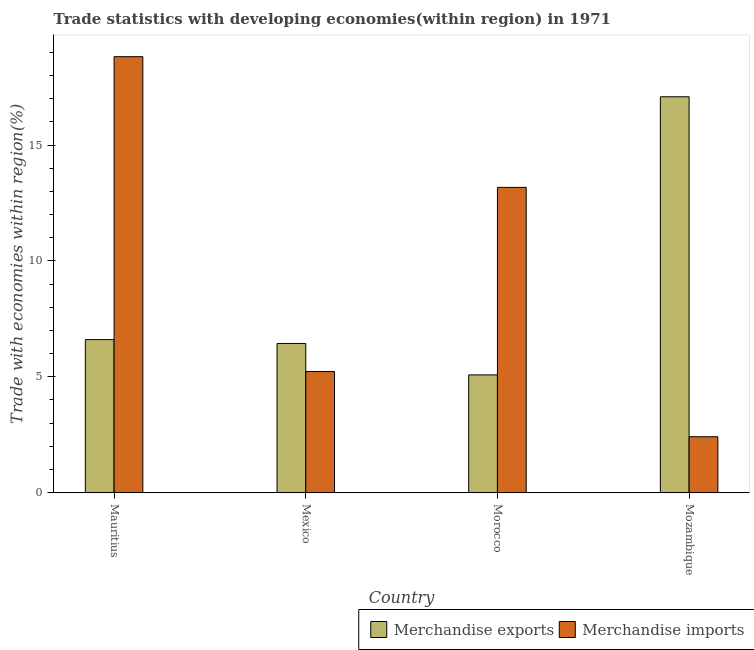How many different coloured bars are there?
Offer a very short reply. 2. How many groups of bars are there?
Give a very brief answer. 4. Are the number of bars on each tick of the X-axis equal?
Provide a short and direct response. Yes. How many bars are there on the 4th tick from the right?
Your answer should be compact. 2. What is the label of the 1st group of bars from the left?
Offer a very short reply. Mauritius. In how many cases, is the number of bars for a given country not equal to the number of legend labels?
Keep it short and to the point. 0. What is the merchandise exports in Mexico?
Ensure brevity in your answer.  6.44. Across all countries, what is the maximum merchandise exports?
Provide a short and direct response. 17.08. Across all countries, what is the minimum merchandise imports?
Give a very brief answer. 2.42. In which country was the merchandise exports maximum?
Your response must be concise. Mozambique. In which country was the merchandise imports minimum?
Give a very brief answer. Mozambique. What is the total merchandise exports in the graph?
Provide a succinct answer. 35.21. What is the difference between the merchandise imports in Mexico and that in Mozambique?
Your response must be concise. 2.81. What is the difference between the merchandise imports in Mexico and the merchandise exports in Mauritius?
Provide a short and direct response. -1.38. What is the average merchandise exports per country?
Give a very brief answer. 8.8. What is the difference between the merchandise imports and merchandise exports in Morocco?
Your answer should be compact. 8.09. In how many countries, is the merchandise imports greater than 15 %?
Make the answer very short. 1. What is the ratio of the merchandise imports in Mauritius to that in Mexico?
Provide a succinct answer. 3.6. Is the difference between the merchandise exports in Mexico and Mozambique greater than the difference between the merchandise imports in Mexico and Mozambique?
Give a very brief answer. No. What is the difference between the highest and the second highest merchandise imports?
Ensure brevity in your answer.  5.64. What is the difference between the highest and the lowest merchandise imports?
Make the answer very short. 16.39. In how many countries, is the merchandise imports greater than the average merchandise imports taken over all countries?
Your answer should be compact. 2. What does the 1st bar from the left in Mozambique represents?
Offer a very short reply. Merchandise exports. Are all the bars in the graph horizontal?
Your response must be concise. No. How many countries are there in the graph?
Offer a very short reply. 4. What is the difference between two consecutive major ticks on the Y-axis?
Provide a short and direct response. 5. Are the values on the major ticks of Y-axis written in scientific E-notation?
Offer a terse response. No. Where does the legend appear in the graph?
Keep it short and to the point. Bottom right. How many legend labels are there?
Provide a succinct answer. 2. How are the legend labels stacked?
Your response must be concise. Horizontal. What is the title of the graph?
Provide a short and direct response. Trade statistics with developing economies(within region) in 1971. What is the label or title of the X-axis?
Offer a very short reply. Country. What is the label or title of the Y-axis?
Your answer should be very brief. Trade with economies within region(%). What is the Trade with economies within region(%) of Merchandise exports in Mauritius?
Your answer should be compact. 6.6. What is the Trade with economies within region(%) in Merchandise imports in Mauritius?
Your answer should be very brief. 18.81. What is the Trade with economies within region(%) in Merchandise exports in Mexico?
Make the answer very short. 6.44. What is the Trade with economies within region(%) of Merchandise imports in Mexico?
Make the answer very short. 5.23. What is the Trade with economies within region(%) in Merchandise exports in Morocco?
Your response must be concise. 5.08. What is the Trade with economies within region(%) of Merchandise imports in Morocco?
Offer a terse response. 13.17. What is the Trade with economies within region(%) in Merchandise exports in Mozambique?
Provide a short and direct response. 17.08. What is the Trade with economies within region(%) of Merchandise imports in Mozambique?
Offer a terse response. 2.42. Across all countries, what is the maximum Trade with economies within region(%) of Merchandise exports?
Keep it short and to the point. 17.08. Across all countries, what is the maximum Trade with economies within region(%) of Merchandise imports?
Your answer should be very brief. 18.81. Across all countries, what is the minimum Trade with economies within region(%) of Merchandise exports?
Make the answer very short. 5.08. Across all countries, what is the minimum Trade with economies within region(%) in Merchandise imports?
Your answer should be very brief. 2.42. What is the total Trade with economies within region(%) in Merchandise exports in the graph?
Make the answer very short. 35.21. What is the total Trade with economies within region(%) in Merchandise imports in the graph?
Provide a succinct answer. 39.63. What is the difference between the Trade with economies within region(%) in Merchandise exports in Mauritius and that in Mexico?
Make the answer very short. 0.17. What is the difference between the Trade with economies within region(%) in Merchandise imports in Mauritius and that in Mexico?
Make the answer very short. 13.58. What is the difference between the Trade with economies within region(%) in Merchandise exports in Mauritius and that in Morocco?
Your response must be concise. 1.52. What is the difference between the Trade with economies within region(%) of Merchandise imports in Mauritius and that in Morocco?
Your response must be concise. 5.64. What is the difference between the Trade with economies within region(%) in Merchandise exports in Mauritius and that in Mozambique?
Offer a very short reply. -10.48. What is the difference between the Trade with economies within region(%) of Merchandise imports in Mauritius and that in Mozambique?
Give a very brief answer. 16.39. What is the difference between the Trade with economies within region(%) of Merchandise exports in Mexico and that in Morocco?
Ensure brevity in your answer.  1.36. What is the difference between the Trade with economies within region(%) of Merchandise imports in Mexico and that in Morocco?
Offer a very short reply. -7.94. What is the difference between the Trade with economies within region(%) of Merchandise exports in Mexico and that in Mozambique?
Make the answer very short. -10.64. What is the difference between the Trade with economies within region(%) of Merchandise imports in Mexico and that in Mozambique?
Your answer should be compact. 2.81. What is the difference between the Trade with economies within region(%) in Merchandise exports in Morocco and that in Mozambique?
Provide a short and direct response. -12. What is the difference between the Trade with economies within region(%) of Merchandise imports in Morocco and that in Mozambique?
Your response must be concise. 10.76. What is the difference between the Trade with economies within region(%) of Merchandise exports in Mauritius and the Trade with economies within region(%) of Merchandise imports in Mexico?
Offer a terse response. 1.38. What is the difference between the Trade with economies within region(%) in Merchandise exports in Mauritius and the Trade with economies within region(%) in Merchandise imports in Morocco?
Ensure brevity in your answer.  -6.57. What is the difference between the Trade with economies within region(%) in Merchandise exports in Mauritius and the Trade with economies within region(%) in Merchandise imports in Mozambique?
Your answer should be compact. 4.19. What is the difference between the Trade with economies within region(%) of Merchandise exports in Mexico and the Trade with economies within region(%) of Merchandise imports in Morocco?
Give a very brief answer. -6.73. What is the difference between the Trade with economies within region(%) in Merchandise exports in Mexico and the Trade with economies within region(%) in Merchandise imports in Mozambique?
Offer a very short reply. 4.02. What is the difference between the Trade with economies within region(%) of Merchandise exports in Morocco and the Trade with economies within region(%) of Merchandise imports in Mozambique?
Keep it short and to the point. 2.67. What is the average Trade with economies within region(%) in Merchandise exports per country?
Give a very brief answer. 8.8. What is the average Trade with economies within region(%) of Merchandise imports per country?
Your answer should be very brief. 9.91. What is the difference between the Trade with economies within region(%) of Merchandise exports and Trade with economies within region(%) of Merchandise imports in Mauritius?
Your answer should be compact. -12.21. What is the difference between the Trade with economies within region(%) in Merchandise exports and Trade with economies within region(%) in Merchandise imports in Mexico?
Offer a terse response. 1.21. What is the difference between the Trade with economies within region(%) in Merchandise exports and Trade with economies within region(%) in Merchandise imports in Morocco?
Give a very brief answer. -8.09. What is the difference between the Trade with economies within region(%) in Merchandise exports and Trade with economies within region(%) in Merchandise imports in Mozambique?
Ensure brevity in your answer.  14.67. What is the ratio of the Trade with economies within region(%) of Merchandise exports in Mauritius to that in Mexico?
Your answer should be compact. 1.03. What is the ratio of the Trade with economies within region(%) of Merchandise imports in Mauritius to that in Mexico?
Offer a very short reply. 3.6. What is the ratio of the Trade with economies within region(%) in Merchandise exports in Mauritius to that in Morocco?
Your answer should be very brief. 1.3. What is the ratio of the Trade with economies within region(%) in Merchandise imports in Mauritius to that in Morocco?
Your answer should be very brief. 1.43. What is the ratio of the Trade with economies within region(%) of Merchandise exports in Mauritius to that in Mozambique?
Offer a very short reply. 0.39. What is the ratio of the Trade with economies within region(%) in Merchandise imports in Mauritius to that in Mozambique?
Provide a succinct answer. 7.79. What is the ratio of the Trade with economies within region(%) of Merchandise exports in Mexico to that in Morocco?
Ensure brevity in your answer.  1.27. What is the ratio of the Trade with economies within region(%) in Merchandise imports in Mexico to that in Morocco?
Your response must be concise. 0.4. What is the ratio of the Trade with economies within region(%) in Merchandise exports in Mexico to that in Mozambique?
Give a very brief answer. 0.38. What is the ratio of the Trade with economies within region(%) in Merchandise imports in Mexico to that in Mozambique?
Your response must be concise. 2.16. What is the ratio of the Trade with economies within region(%) in Merchandise exports in Morocco to that in Mozambique?
Your response must be concise. 0.3. What is the ratio of the Trade with economies within region(%) of Merchandise imports in Morocco to that in Mozambique?
Your answer should be compact. 5.45. What is the difference between the highest and the second highest Trade with economies within region(%) in Merchandise exports?
Offer a very short reply. 10.48. What is the difference between the highest and the second highest Trade with economies within region(%) of Merchandise imports?
Your answer should be very brief. 5.64. What is the difference between the highest and the lowest Trade with economies within region(%) of Merchandise exports?
Make the answer very short. 12. What is the difference between the highest and the lowest Trade with economies within region(%) in Merchandise imports?
Provide a succinct answer. 16.39. 